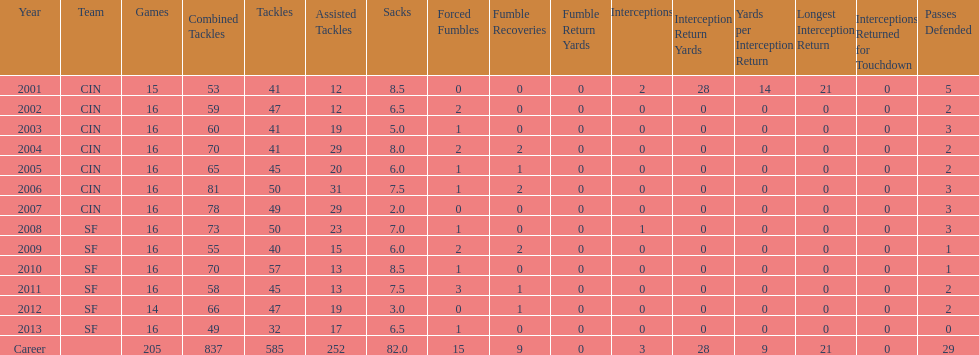How many sacks did this player obtain in his first five years? 34. 